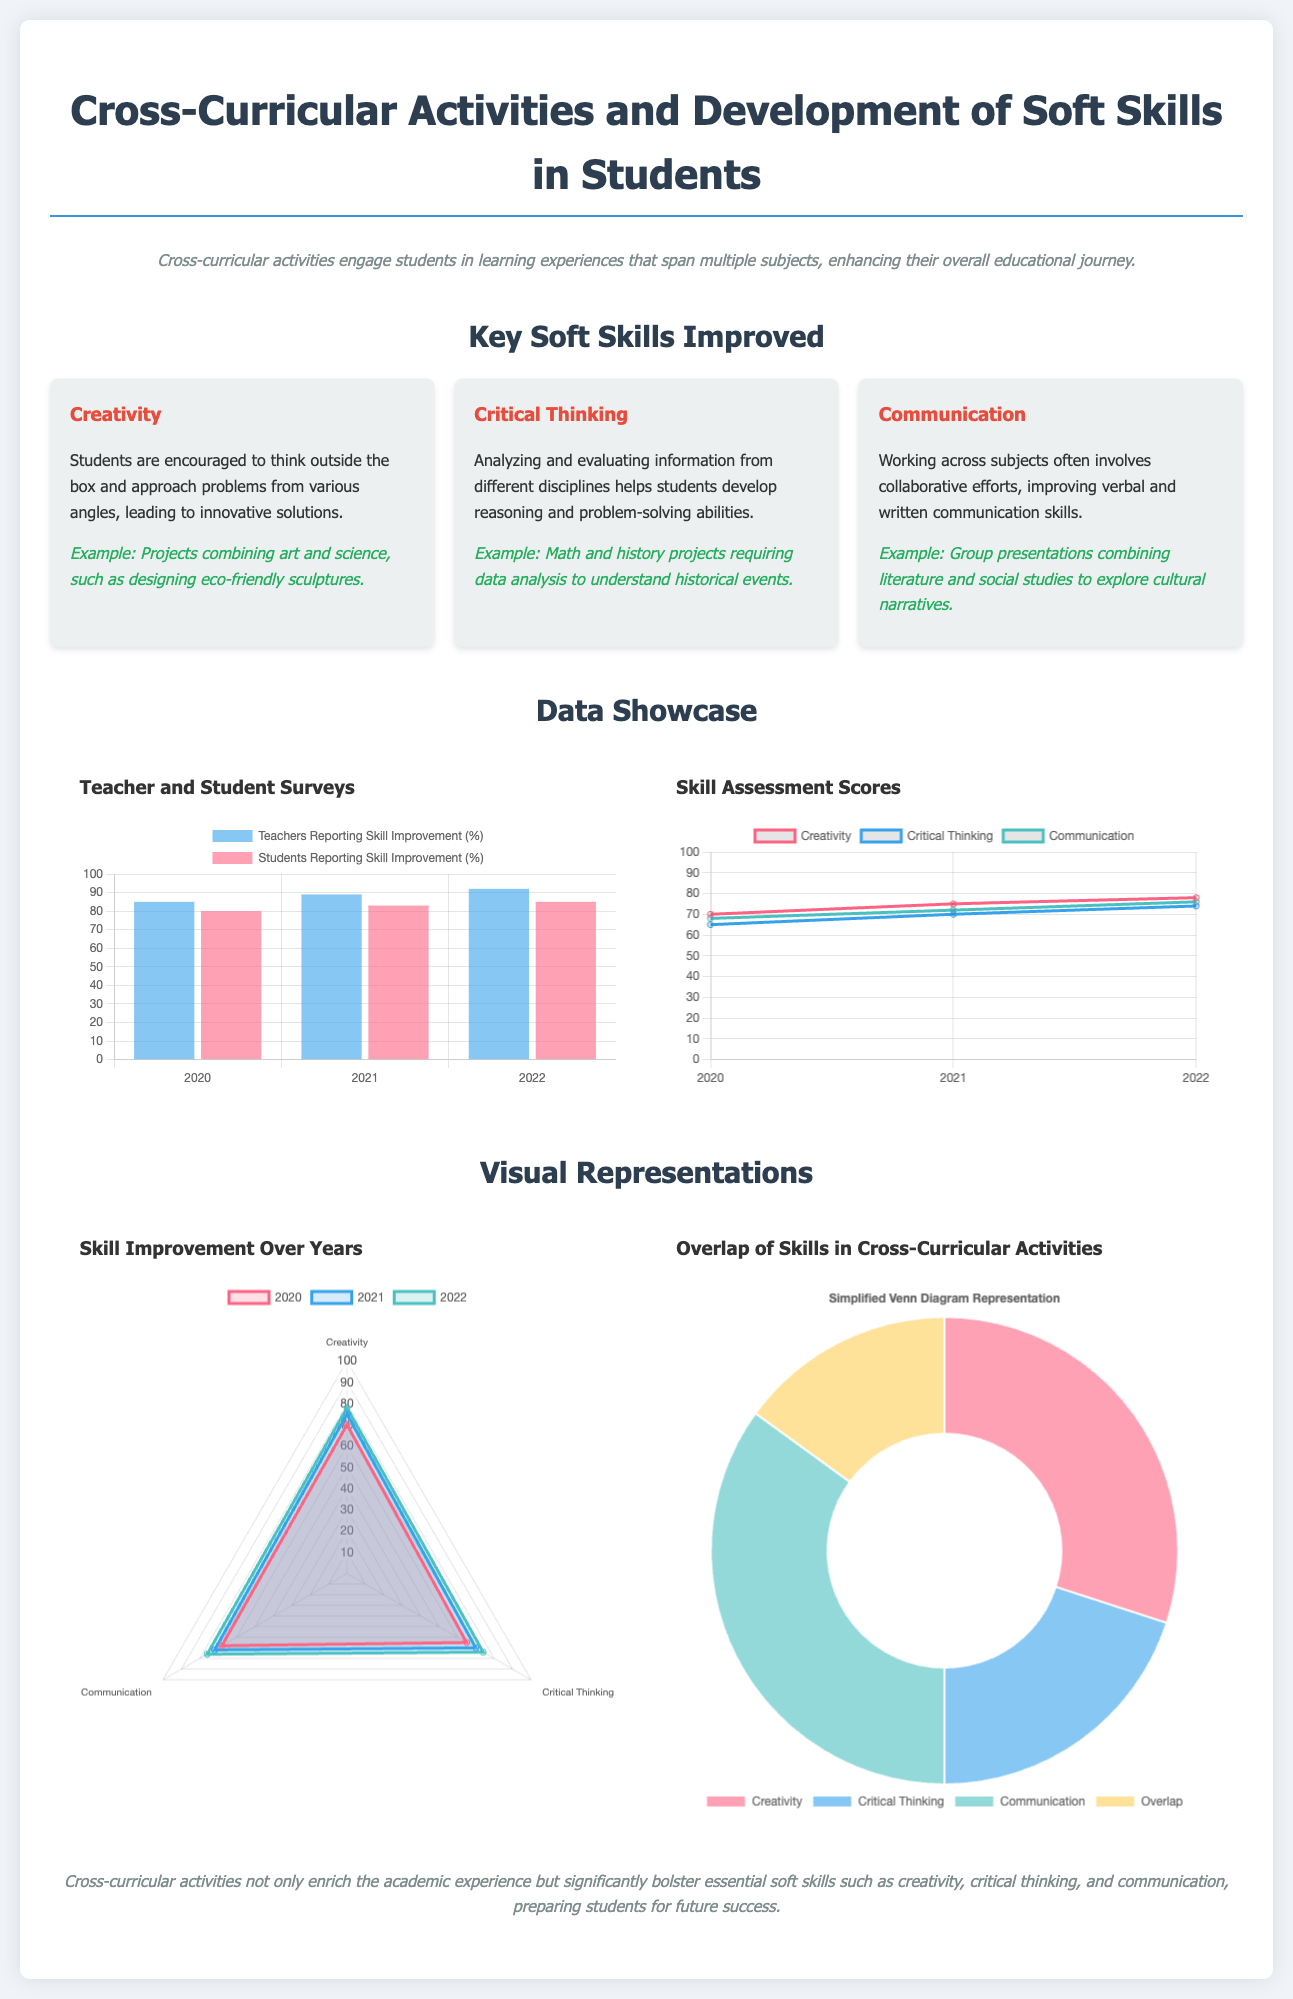What is the title of the infographic? The title is stated prominently at the top of the infographic.
Answer: Cross-Curricular Activities and Development of Soft Skills in Students What year saw the highest percentage of teachers reporting skill improvement? The chart showing teacher reports indicates this year.
Answer: 2022 What percentage of students reported skill improvement in 2021? The data from the student surveys shows this percentage directly.
Answer: 83 Which skill had the lowest assessment score in 2020? A comparison of skill assessment data shows which skill had the lowest score that year.
Answer: Critical Thinking What color represents creativity in the skill assessment chart? The visual representation in the document uses specific colors for each skill.
Answer: rgb(255, 99, 132) In which year did creativity reach a score of 78? The line chart indicates the score for this skill in the mentioned year.
Answer: 2022 How many soft skills are mentioned in the infographic? The key skills discussed are listed in a grid format within the document.
Answer: 3 What visual representation is used to show the overlap of skills? The document specifies how the overlap is illustrated.
Answer: Simplified Venn Diagram What example is given for creativity? The document includes specific activities that exemplify each skill.
Answer: Designing eco-friendly sculptures 